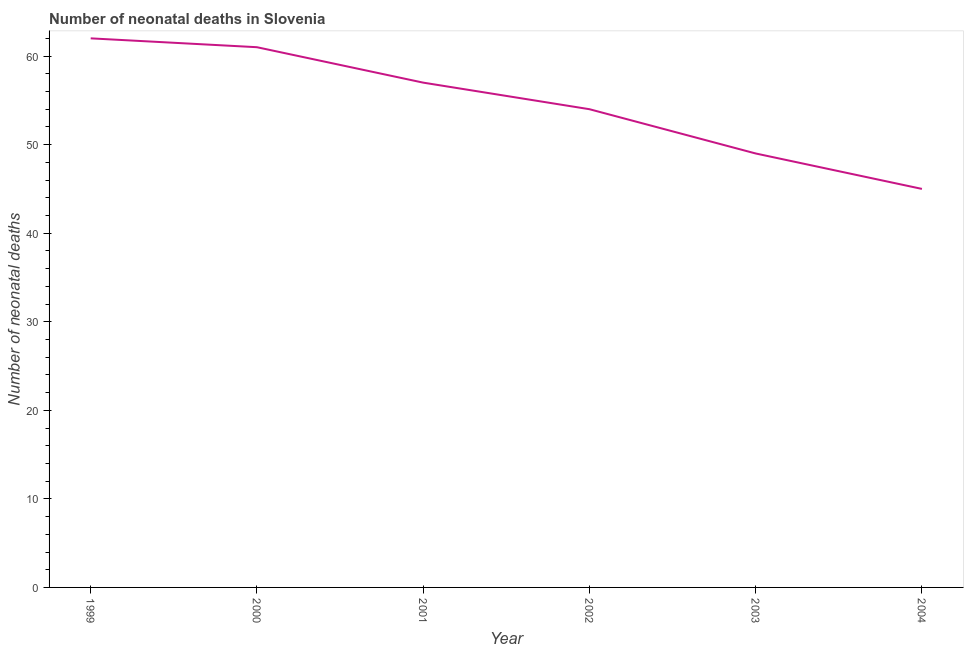What is the number of neonatal deaths in 2002?
Keep it short and to the point. 54. Across all years, what is the maximum number of neonatal deaths?
Your answer should be compact. 62. Across all years, what is the minimum number of neonatal deaths?
Offer a terse response. 45. In which year was the number of neonatal deaths minimum?
Ensure brevity in your answer.  2004. What is the sum of the number of neonatal deaths?
Ensure brevity in your answer.  328. What is the difference between the number of neonatal deaths in 1999 and 2000?
Provide a succinct answer. 1. What is the average number of neonatal deaths per year?
Provide a short and direct response. 54.67. What is the median number of neonatal deaths?
Your response must be concise. 55.5. Do a majority of the years between 2001 and 2003 (inclusive) have number of neonatal deaths greater than 38 ?
Keep it short and to the point. Yes. What is the ratio of the number of neonatal deaths in 2000 to that in 2001?
Make the answer very short. 1.07. Is the difference between the number of neonatal deaths in 2000 and 2003 greater than the difference between any two years?
Provide a succinct answer. No. Is the sum of the number of neonatal deaths in 2000 and 2002 greater than the maximum number of neonatal deaths across all years?
Make the answer very short. Yes. What is the difference between the highest and the lowest number of neonatal deaths?
Ensure brevity in your answer.  17. Does the number of neonatal deaths monotonically increase over the years?
Your response must be concise. No. How many years are there in the graph?
Ensure brevity in your answer.  6. What is the difference between two consecutive major ticks on the Y-axis?
Your answer should be compact. 10. Does the graph contain any zero values?
Make the answer very short. No. Does the graph contain grids?
Ensure brevity in your answer.  No. What is the title of the graph?
Provide a short and direct response. Number of neonatal deaths in Slovenia. What is the label or title of the Y-axis?
Provide a succinct answer. Number of neonatal deaths. What is the Number of neonatal deaths in 1999?
Make the answer very short. 62. What is the Number of neonatal deaths in 2000?
Give a very brief answer. 61. What is the Number of neonatal deaths in 2002?
Make the answer very short. 54. What is the Number of neonatal deaths in 2003?
Keep it short and to the point. 49. What is the difference between the Number of neonatal deaths in 1999 and 2000?
Give a very brief answer. 1. What is the difference between the Number of neonatal deaths in 2000 and 2002?
Provide a succinct answer. 7. What is the difference between the Number of neonatal deaths in 2000 and 2003?
Your answer should be very brief. 12. What is the difference between the Number of neonatal deaths in 2000 and 2004?
Make the answer very short. 16. What is the difference between the Number of neonatal deaths in 2001 and 2002?
Your response must be concise. 3. What is the difference between the Number of neonatal deaths in 2001 and 2003?
Give a very brief answer. 8. What is the difference between the Number of neonatal deaths in 2002 and 2003?
Keep it short and to the point. 5. What is the difference between the Number of neonatal deaths in 2003 and 2004?
Keep it short and to the point. 4. What is the ratio of the Number of neonatal deaths in 1999 to that in 2001?
Give a very brief answer. 1.09. What is the ratio of the Number of neonatal deaths in 1999 to that in 2002?
Your answer should be very brief. 1.15. What is the ratio of the Number of neonatal deaths in 1999 to that in 2003?
Your answer should be compact. 1.26. What is the ratio of the Number of neonatal deaths in 1999 to that in 2004?
Make the answer very short. 1.38. What is the ratio of the Number of neonatal deaths in 2000 to that in 2001?
Your answer should be very brief. 1.07. What is the ratio of the Number of neonatal deaths in 2000 to that in 2002?
Give a very brief answer. 1.13. What is the ratio of the Number of neonatal deaths in 2000 to that in 2003?
Your answer should be very brief. 1.25. What is the ratio of the Number of neonatal deaths in 2000 to that in 2004?
Offer a very short reply. 1.36. What is the ratio of the Number of neonatal deaths in 2001 to that in 2002?
Your response must be concise. 1.06. What is the ratio of the Number of neonatal deaths in 2001 to that in 2003?
Make the answer very short. 1.16. What is the ratio of the Number of neonatal deaths in 2001 to that in 2004?
Offer a very short reply. 1.27. What is the ratio of the Number of neonatal deaths in 2002 to that in 2003?
Offer a terse response. 1.1. What is the ratio of the Number of neonatal deaths in 2003 to that in 2004?
Keep it short and to the point. 1.09. 